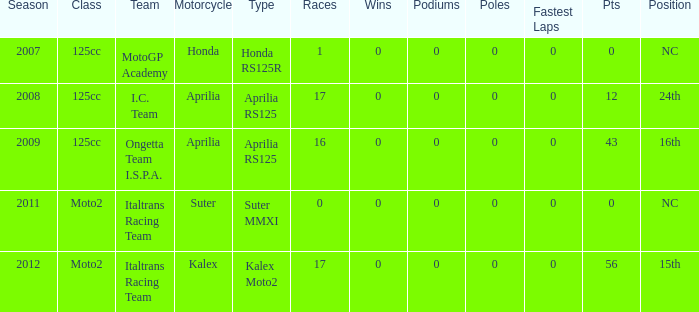What's the count of poles in the season when the team used a kalex motorcycle? 0.0. 